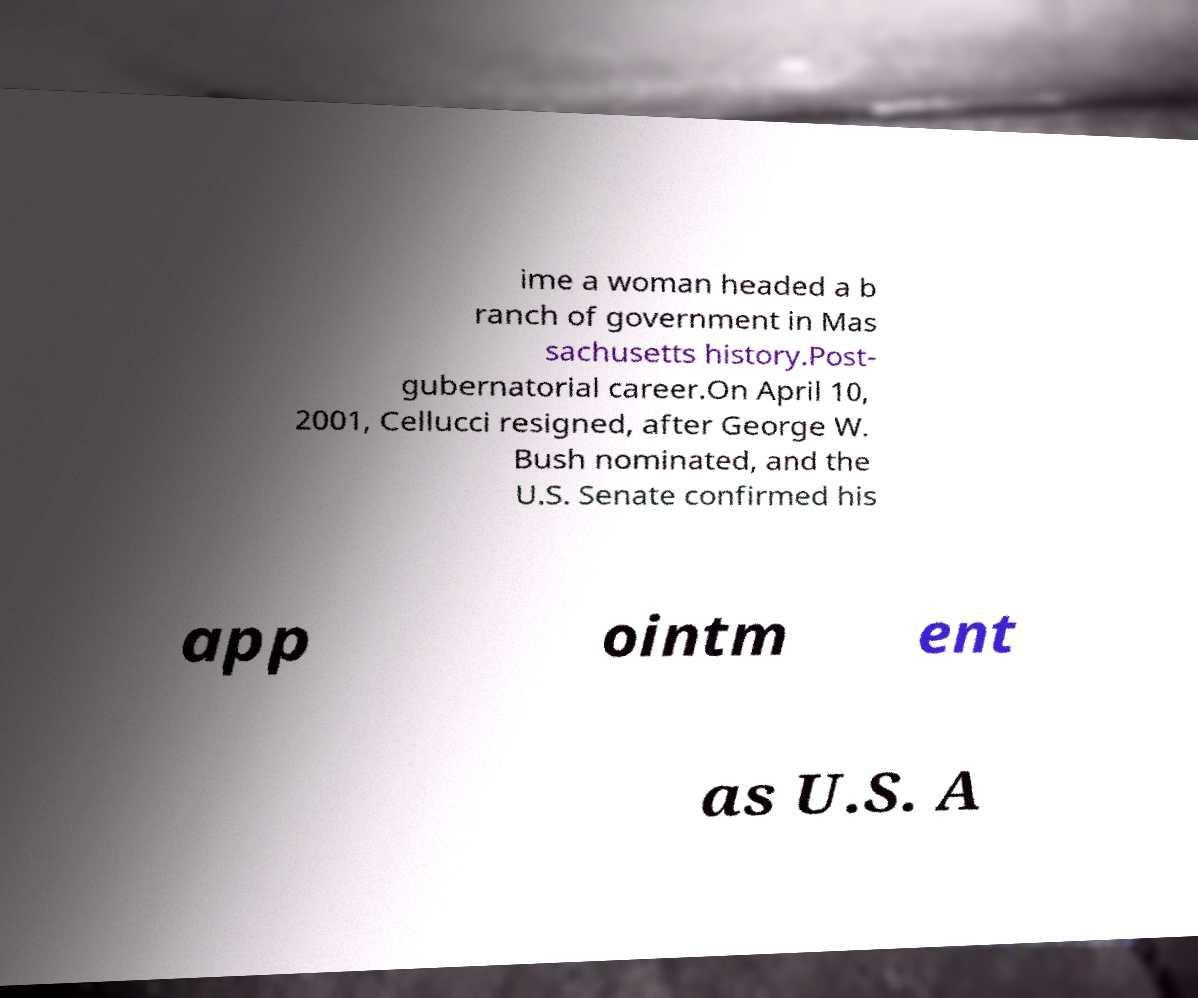Please read and relay the text visible in this image. What does it say? ime a woman headed a b ranch of government in Mas sachusetts history.Post- gubernatorial career.On April 10, 2001, Cellucci resigned, after George W. Bush nominated, and the U.S. Senate confirmed his app ointm ent as U.S. A 